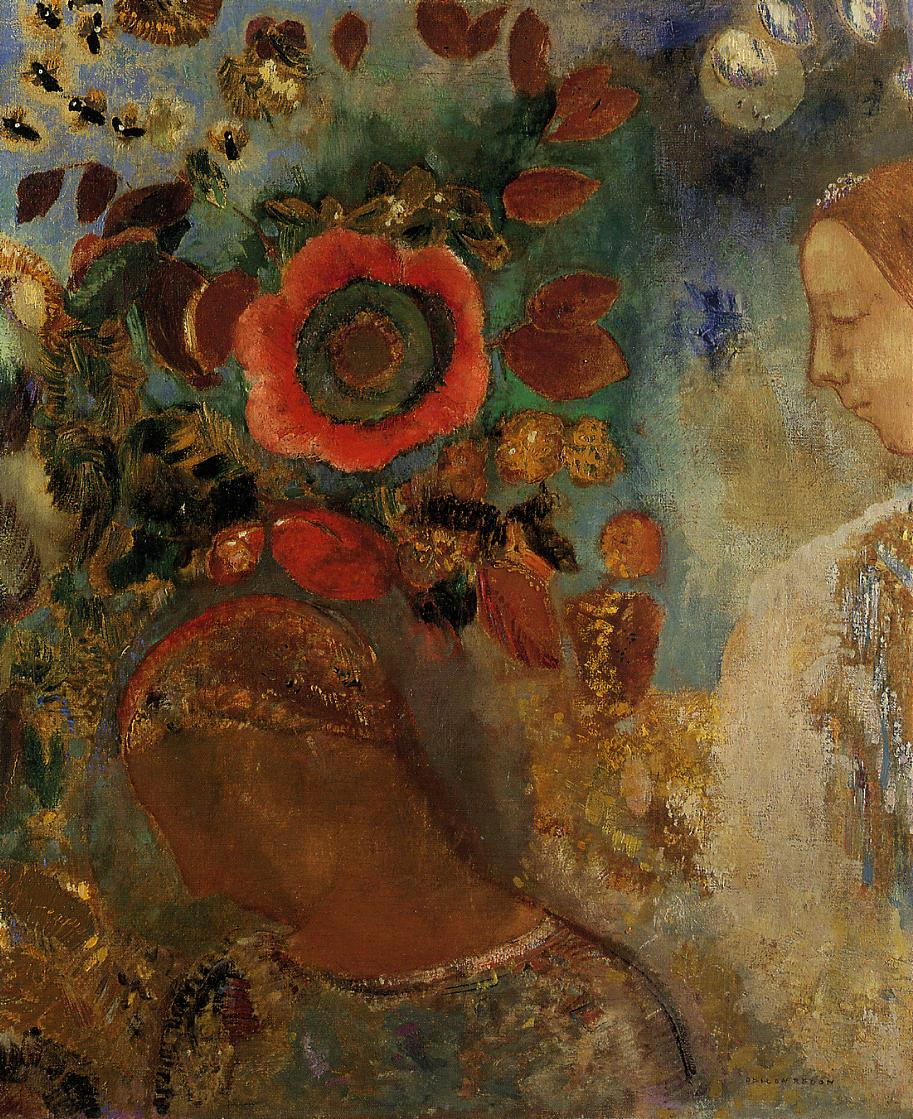What kind of setting or story can you imagine this image belongs to? This image could belong to a story of a mystical garden, a hidden oasis where the boundary between the physical and the spiritual realm is blurred. The central figure might be a nature spirit, guardian of this lush haven, representing the nurturing force of nature. The setting could be somewhere out of time, a utopian vision where the vibrancy of life and nature's unrestrained growth reign supreme. Each element in the painting, from the largest flower to the tiniest leaf, could have its own story, contributing to the tapestry of this enchanted place. 